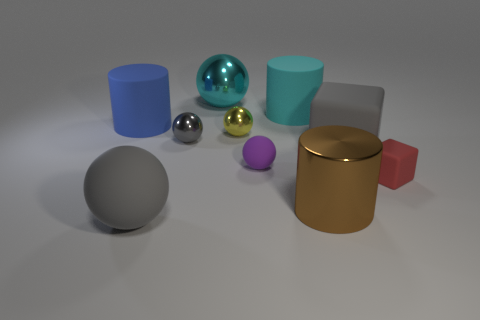Subtract 1 spheres. How many spheres are left? 4 Subtract all yellow metal spheres. How many spheres are left? 4 Subtract all yellow spheres. How many spheres are left? 4 Subtract all brown balls. Subtract all purple blocks. How many balls are left? 5 Subtract all cubes. How many objects are left? 8 Add 8 large shiny things. How many large shiny things exist? 10 Subtract 1 cyan balls. How many objects are left? 9 Subtract all large brown objects. Subtract all large gray balls. How many objects are left? 8 Add 1 matte blocks. How many matte blocks are left? 3 